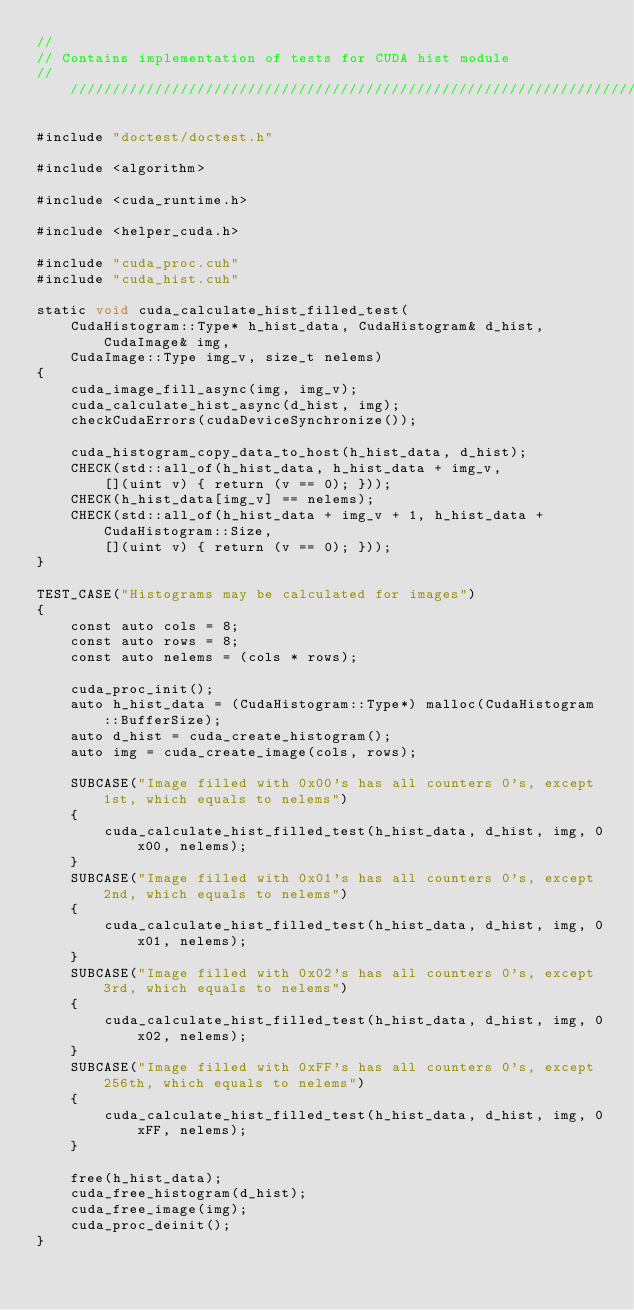<code> <loc_0><loc_0><loc_500><loc_500><_Cuda_>//
// Contains implementation of tests for CUDA hist module
///////////////////////////////////////////////////////////////////////////////

#include "doctest/doctest.h"

#include <algorithm>

#include <cuda_runtime.h>

#include <helper_cuda.h>

#include "cuda_proc.cuh"
#include "cuda_hist.cuh"

static void cuda_calculate_hist_filled_test(
    CudaHistogram::Type* h_hist_data, CudaHistogram& d_hist, CudaImage& img, 
    CudaImage::Type img_v, size_t nelems)
{
    cuda_image_fill_async(img, img_v);
    cuda_calculate_hist_async(d_hist, img);
    checkCudaErrors(cudaDeviceSynchronize());

    cuda_histogram_copy_data_to_host(h_hist_data, d_hist);
    CHECK(std::all_of(h_hist_data, h_hist_data + img_v,
        [](uint v) { return (v == 0); }));
    CHECK(h_hist_data[img_v] == nelems);
    CHECK(std::all_of(h_hist_data + img_v + 1, h_hist_data + CudaHistogram::Size,
        [](uint v) { return (v == 0); }));
}

TEST_CASE("Histograms may be calculated for images")
{
	const auto cols = 8;
	const auto rows = 8;
    const auto nelems = (cols * rows);

    cuda_proc_init();
    auto h_hist_data = (CudaHistogram::Type*) malloc(CudaHistogram::BufferSize);
    auto d_hist = cuda_create_histogram();
    auto img = cuda_create_image(cols, rows);

    SUBCASE("Image filled with 0x00's has all counters 0's, except 1st, which equals to nelems")
    {
        cuda_calculate_hist_filled_test(h_hist_data, d_hist, img, 0x00, nelems);
    }
    SUBCASE("Image filled with 0x01's has all counters 0's, except 2nd, which equals to nelems")
    {
        cuda_calculate_hist_filled_test(h_hist_data, d_hist, img, 0x01, nelems);
    }
    SUBCASE("Image filled with 0x02's has all counters 0's, except 3rd, which equals to nelems")
    {
        cuda_calculate_hist_filled_test(h_hist_data, d_hist, img, 0x02, nelems);
    }
    SUBCASE("Image filled with 0xFF's has all counters 0's, except 256th, which equals to nelems")
    {
        cuda_calculate_hist_filled_test(h_hist_data, d_hist, img, 0xFF, nelems);
    }

    free(h_hist_data);
    cuda_free_histogram(d_hist);
    cuda_free_image(img);
    cuda_proc_deinit();
}

</code> 